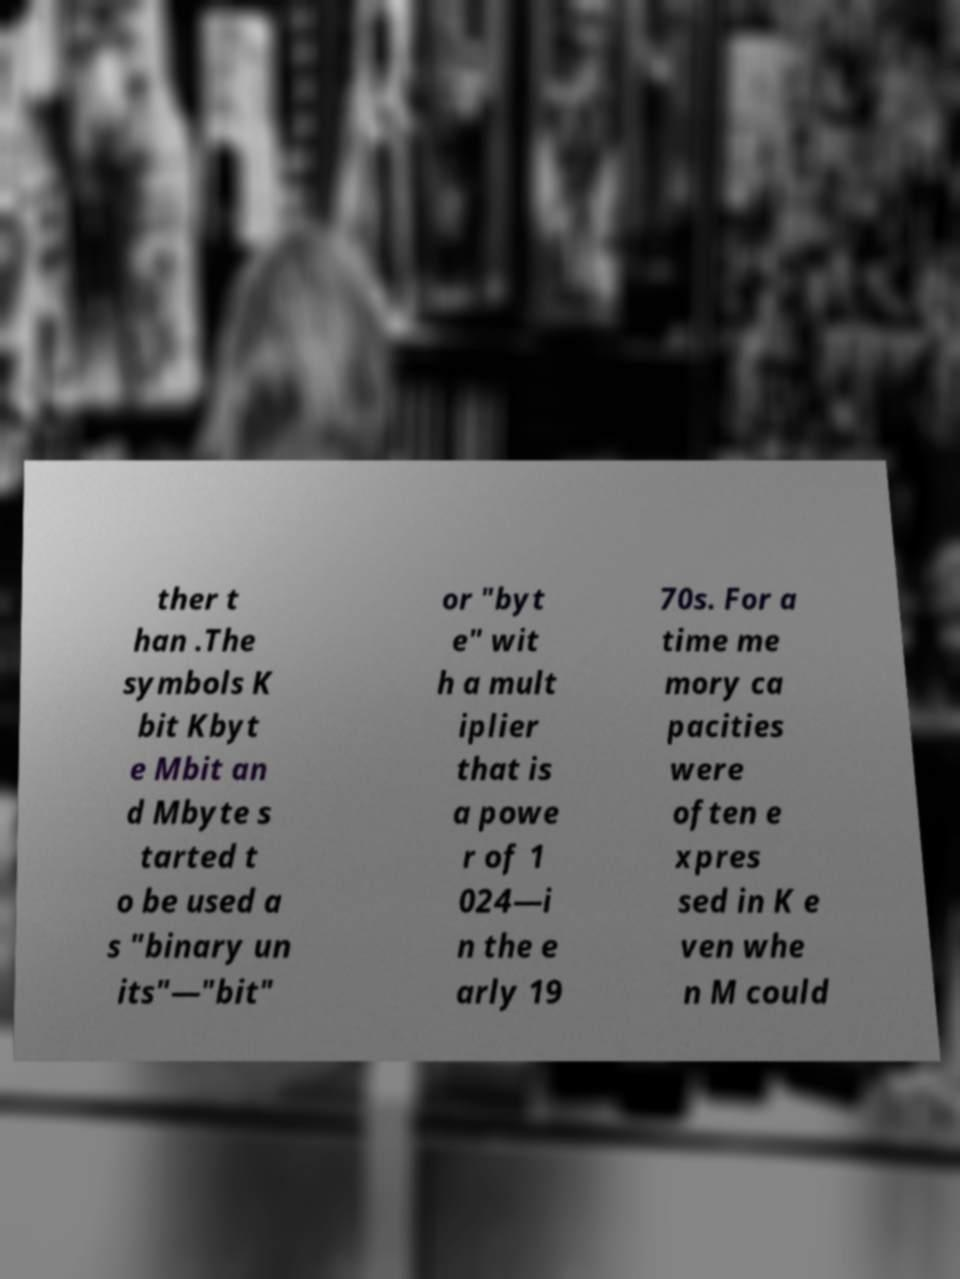There's text embedded in this image that I need extracted. Can you transcribe it verbatim? ther t han .The symbols K bit Kbyt e Mbit an d Mbyte s tarted t o be used a s "binary un its"—"bit" or "byt e" wit h a mult iplier that is a powe r of 1 024—i n the e arly 19 70s. For a time me mory ca pacities were often e xpres sed in K e ven whe n M could 